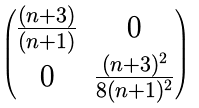Convert formula to latex. <formula><loc_0><loc_0><loc_500><loc_500>\begin{pmatrix} \frac { ( n + 3 ) } { ( n + 1 ) } & 0 \\ 0 & \frac { ( n + 3 ) ^ { 2 } } { 8 ( n + 1 ) ^ { 2 } } \end{pmatrix}</formula> 